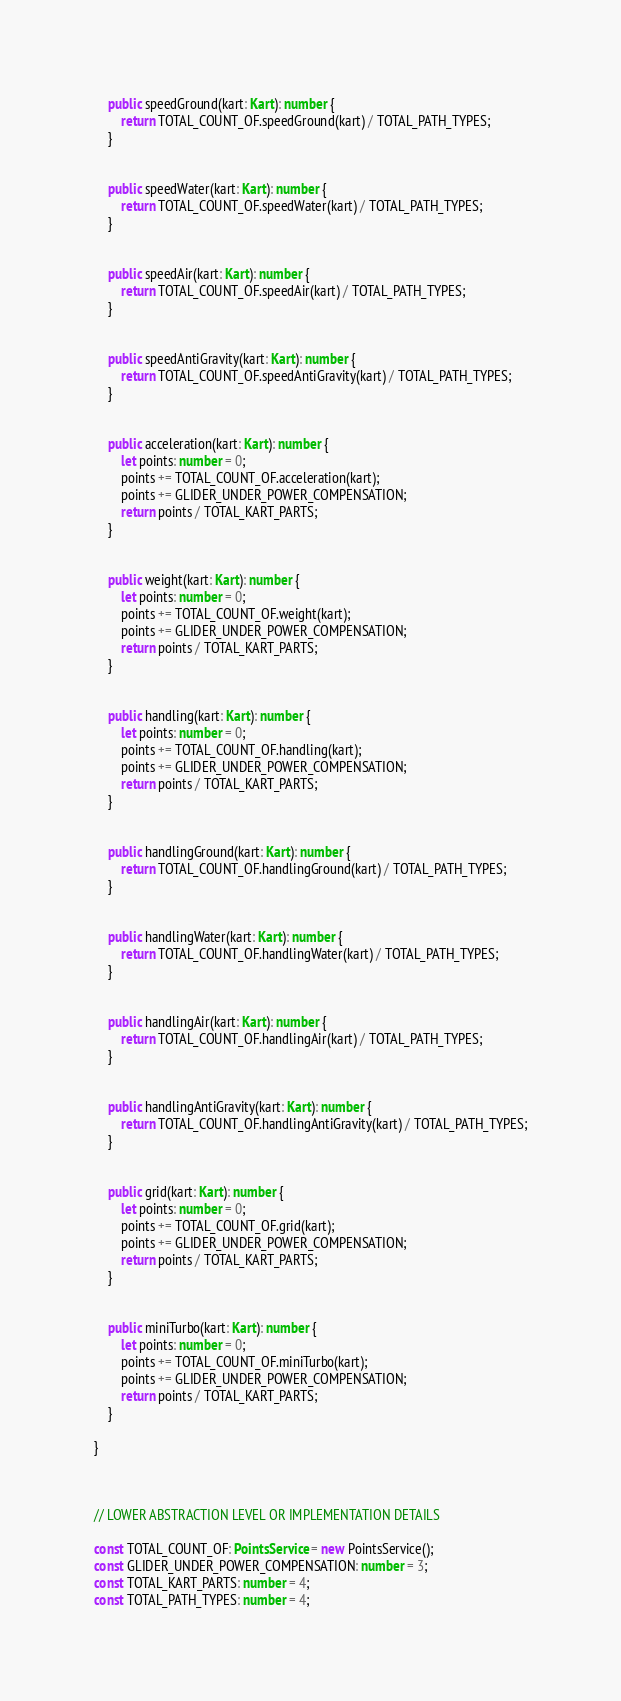<code> <loc_0><loc_0><loc_500><loc_500><_TypeScript_>

    public speedGround(kart: Kart): number {
        return TOTAL_COUNT_OF.speedGround(kart) / TOTAL_PATH_TYPES;
    }


    public speedWater(kart: Kart): number {
        return TOTAL_COUNT_OF.speedWater(kart) / TOTAL_PATH_TYPES;
    }


    public speedAir(kart: Kart): number {
        return TOTAL_COUNT_OF.speedAir(kart) / TOTAL_PATH_TYPES;
    }


    public speedAntiGravity(kart: Kart): number {
        return TOTAL_COUNT_OF.speedAntiGravity(kart) / TOTAL_PATH_TYPES;
    }

    
    public acceleration(kart: Kart): number {
        let points: number = 0;
        points += TOTAL_COUNT_OF.acceleration(kart);
        points += GLIDER_UNDER_POWER_COMPENSATION;
        return points / TOTAL_KART_PARTS;
    }

    
    public weight(kart: Kart): number {
        let points: number = 0;
        points += TOTAL_COUNT_OF.weight(kart);
        points += GLIDER_UNDER_POWER_COMPENSATION;
        return points / TOTAL_KART_PARTS;
    }

    
    public handling(kart: Kart): number {
        let points: number = 0;
        points += TOTAL_COUNT_OF.handling(kart);
        points += GLIDER_UNDER_POWER_COMPENSATION;
        return points / TOTAL_KART_PARTS;
    }


    public handlingGround(kart: Kart): number {
        return TOTAL_COUNT_OF.handlingGround(kart) / TOTAL_PATH_TYPES;
    }


    public handlingWater(kart: Kart): number {
        return TOTAL_COUNT_OF.handlingWater(kart) / TOTAL_PATH_TYPES;
    }


    public handlingAir(kart: Kart): number {
        return TOTAL_COUNT_OF.handlingAir(kart) / TOTAL_PATH_TYPES;
    }


    public handlingAntiGravity(kart: Kart): number {
        return TOTAL_COUNT_OF.handlingAntiGravity(kart) / TOTAL_PATH_TYPES;
    }

    
    public grid(kart: Kart): number {
        let points: number = 0;
        points += TOTAL_COUNT_OF.grid(kart);
        points += GLIDER_UNDER_POWER_COMPENSATION;
        return points / TOTAL_KART_PARTS;
    }

    
    public miniTurbo(kart: Kart): number {
        let points: number = 0;
        points += TOTAL_COUNT_OF.miniTurbo(kart);
        points += GLIDER_UNDER_POWER_COMPENSATION;
        return points / TOTAL_KART_PARTS;
    }

}



// LOWER ABSTRACTION LEVEL OR IMPLEMENTATION DETAILS

const TOTAL_COUNT_OF: PointsService = new PointsService();
const GLIDER_UNDER_POWER_COMPENSATION: number = 3;
const TOTAL_KART_PARTS: number = 4;
const TOTAL_PATH_TYPES: number = 4;
</code> 